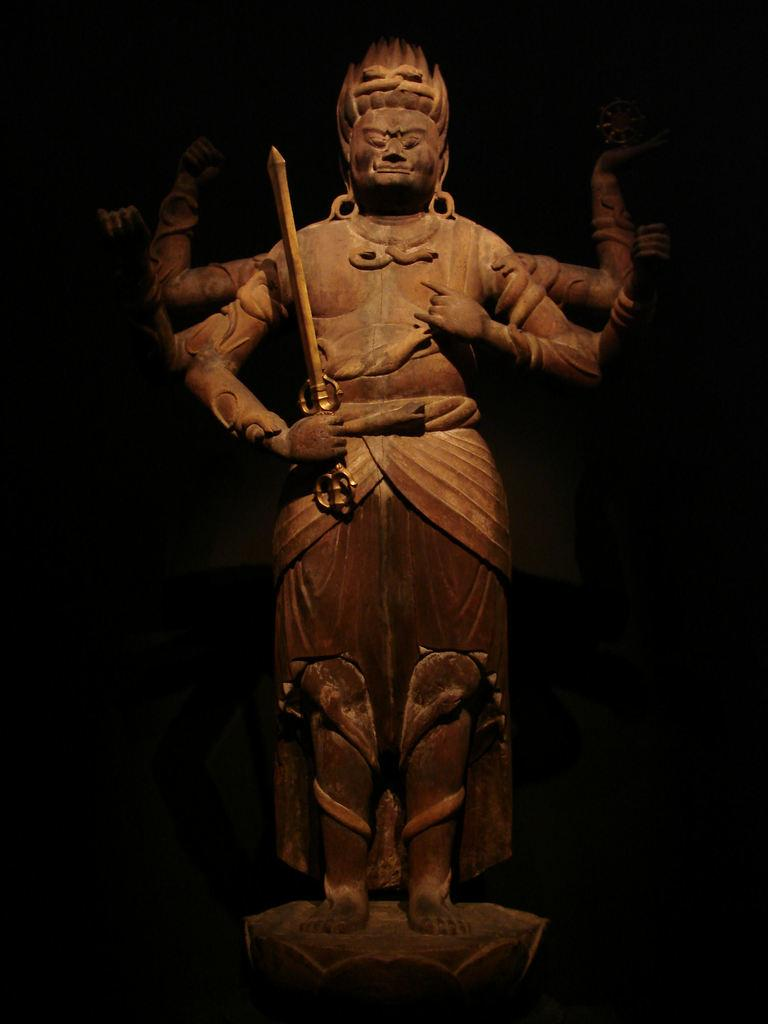What is the main subject in the image? There is a statue in the image. What is the statue holding in its hand? The statue is holding a sword in its hand. How many rabbits can be seen rolling around on the iron in the image? There are no rabbits or iron present in the image; it only features a statue holding a sword. 